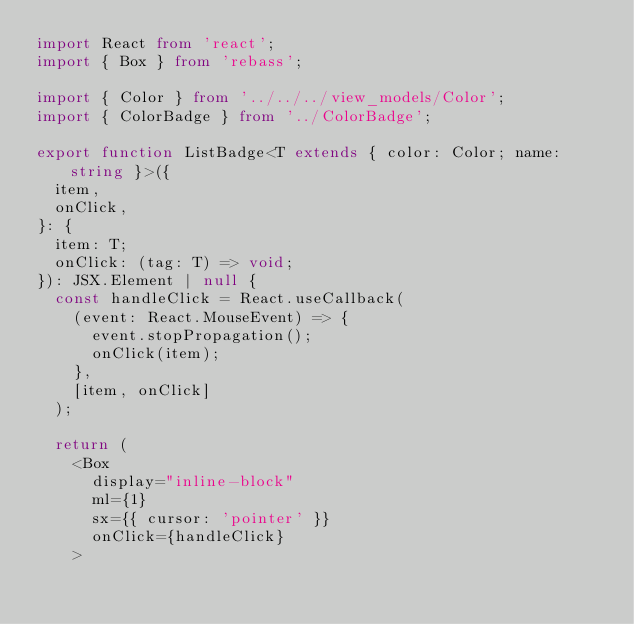Convert code to text. <code><loc_0><loc_0><loc_500><loc_500><_TypeScript_>import React from 'react';
import { Box } from 'rebass';

import { Color } from '../../../view_models/Color';
import { ColorBadge } from '../ColorBadge';

export function ListBadge<T extends { color: Color; name: string }>({
  item,
  onClick,
}: {
  item: T;
  onClick: (tag: T) => void;
}): JSX.Element | null {
  const handleClick = React.useCallback(
    (event: React.MouseEvent) => {
      event.stopPropagation();
      onClick(item);
    },
    [item, onClick]
  );

  return (
    <Box
      display="inline-block"
      ml={1}
      sx={{ cursor: 'pointer' }}
      onClick={handleClick}
    ></code> 